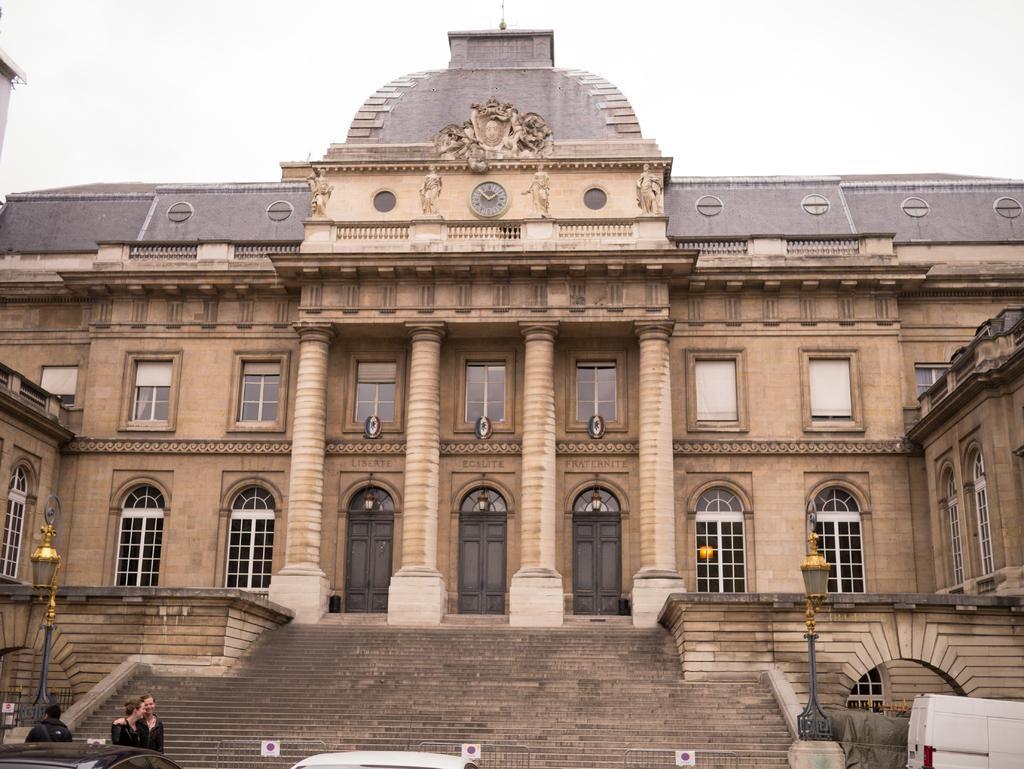Please provide a concise description of this image. In this picture we can observe a building which is in cream color. We can observe four pillars and two poles. There are stairs in front of this building. We can observe two cars and two members standing in front of the car. In the background there is a sky. 